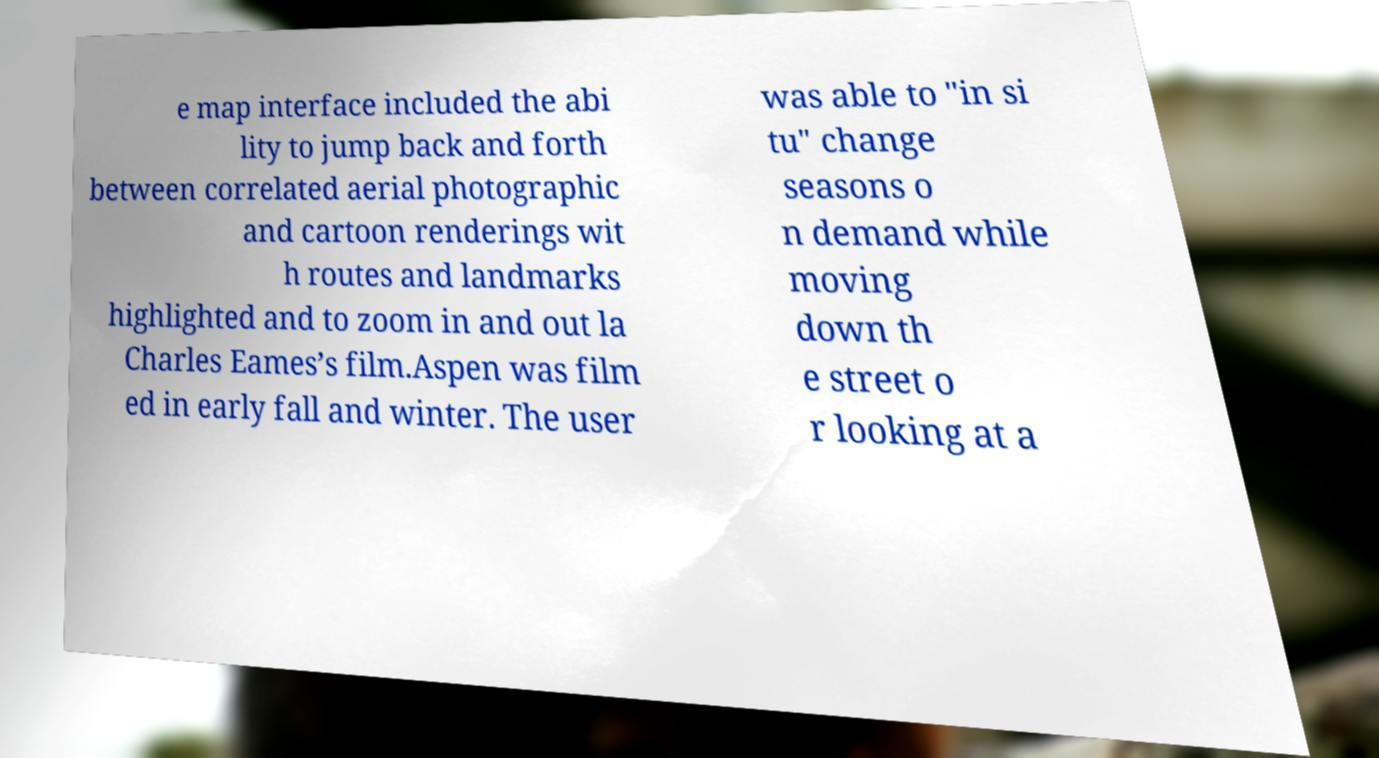Can you accurately transcribe the text from the provided image for me? e map interface included the abi lity to jump back and forth between correlated aerial photographic and cartoon renderings wit h routes and landmarks highlighted and to zoom in and out la Charles Eames’s film.Aspen was film ed in early fall and winter. The user was able to "in si tu" change seasons o n demand while moving down th e street o r looking at a 